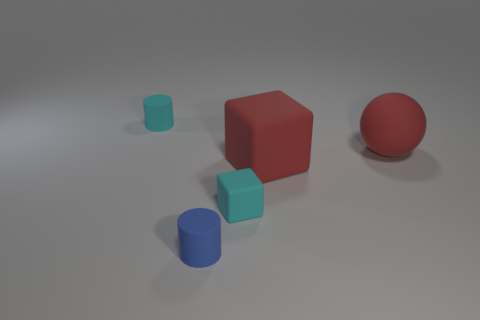What is the material of the other object that is the same shape as the small blue object?
Provide a short and direct response. Rubber. What number of cyan things are on the right side of the matte cylinder behind the ball?
Give a very brief answer. 1. What number of things are either big green metallic cubes or small things to the left of the tiny cyan cube?
Your response must be concise. 2. What material is the tiny cylinder to the left of the cylinder in front of the tiny matte object that is behind the red ball?
Offer a terse response. Rubber. What size is the cyan cylinder that is the same material as the small blue cylinder?
Make the answer very short. Small. There is a matte cylinder right of the tiny matte thing on the left side of the small blue cylinder; what color is it?
Your answer should be compact. Blue. What number of small balls have the same material as the big sphere?
Offer a very short reply. 0. What number of rubber objects are small cyan things or cylinders?
Make the answer very short. 3. There is a sphere that is the same size as the red cube; what is its material?
Your answer should be compact. Rubber. Are there any big red balls made of the same material as the big red cube?
Your response must be concise. Yes. 